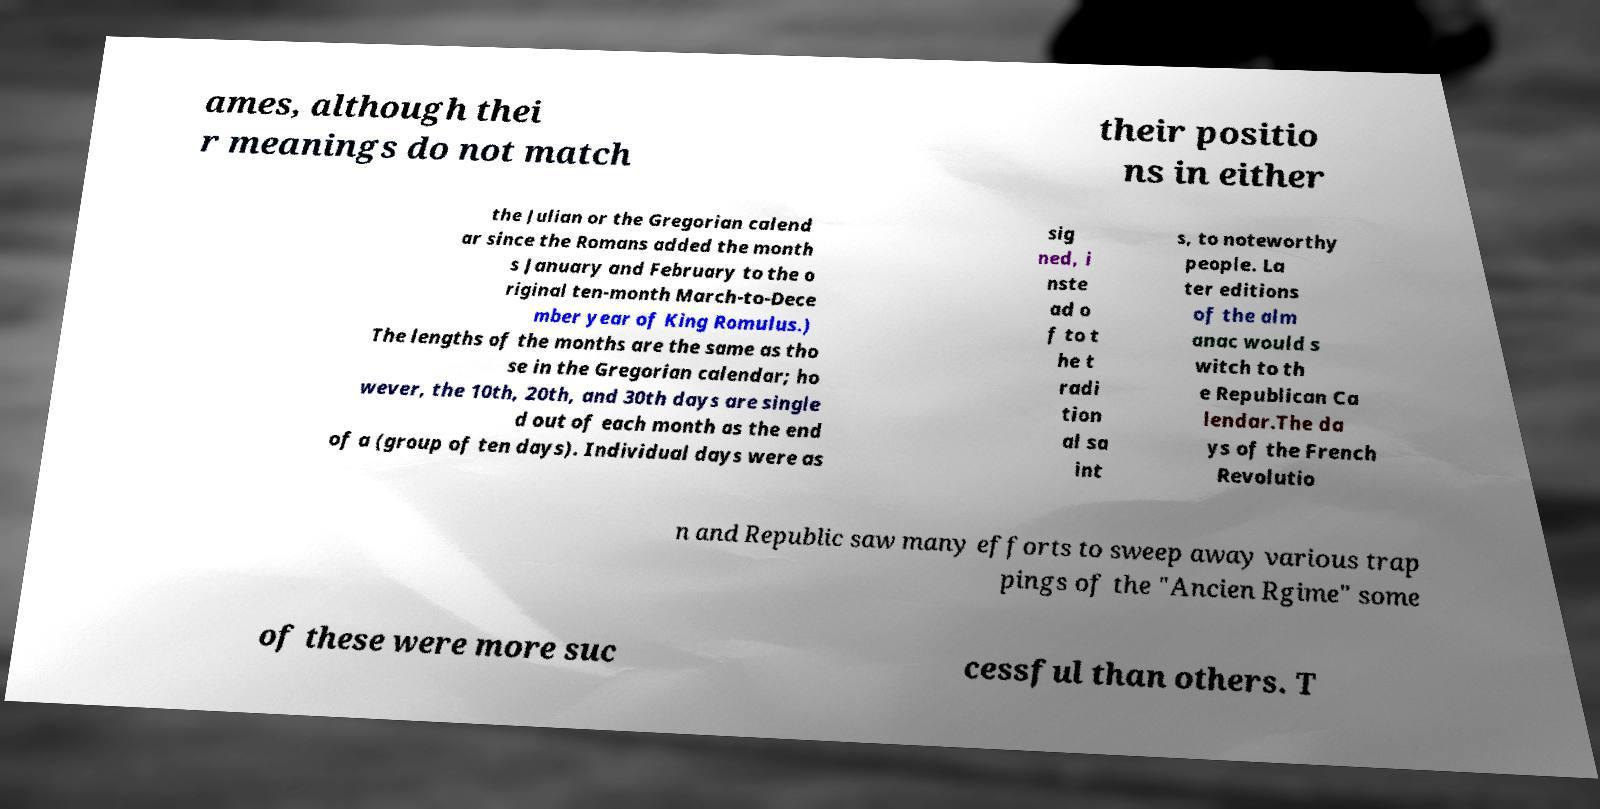Please read and relay the text visible in this image. What does it say? ames, although thei r meanings do not match their positio ns in either the Julian or the Gregorian calend ar since the Romans added the month s January and February to the o riginal ten-month March-to-Dece mber year of King Romulus.) The lengths of the months are the same as tho se in the Gregorian calendar; ho wever, the 10th, 20th, and 30th days are single d out of each month as the end of a (group of ten days). Individual days were as sig ned, i nste ad o f to t he t radi tion al sa int s, to noteworthy people. La ter editions of the alm anac would s witch to th e Republican Ca lendar.The da ys of the French Revolutio n and Republic saw many efforts to sweep away various trap pings of the "Ancien Rgime" some of these were more suc cessful than others. T 